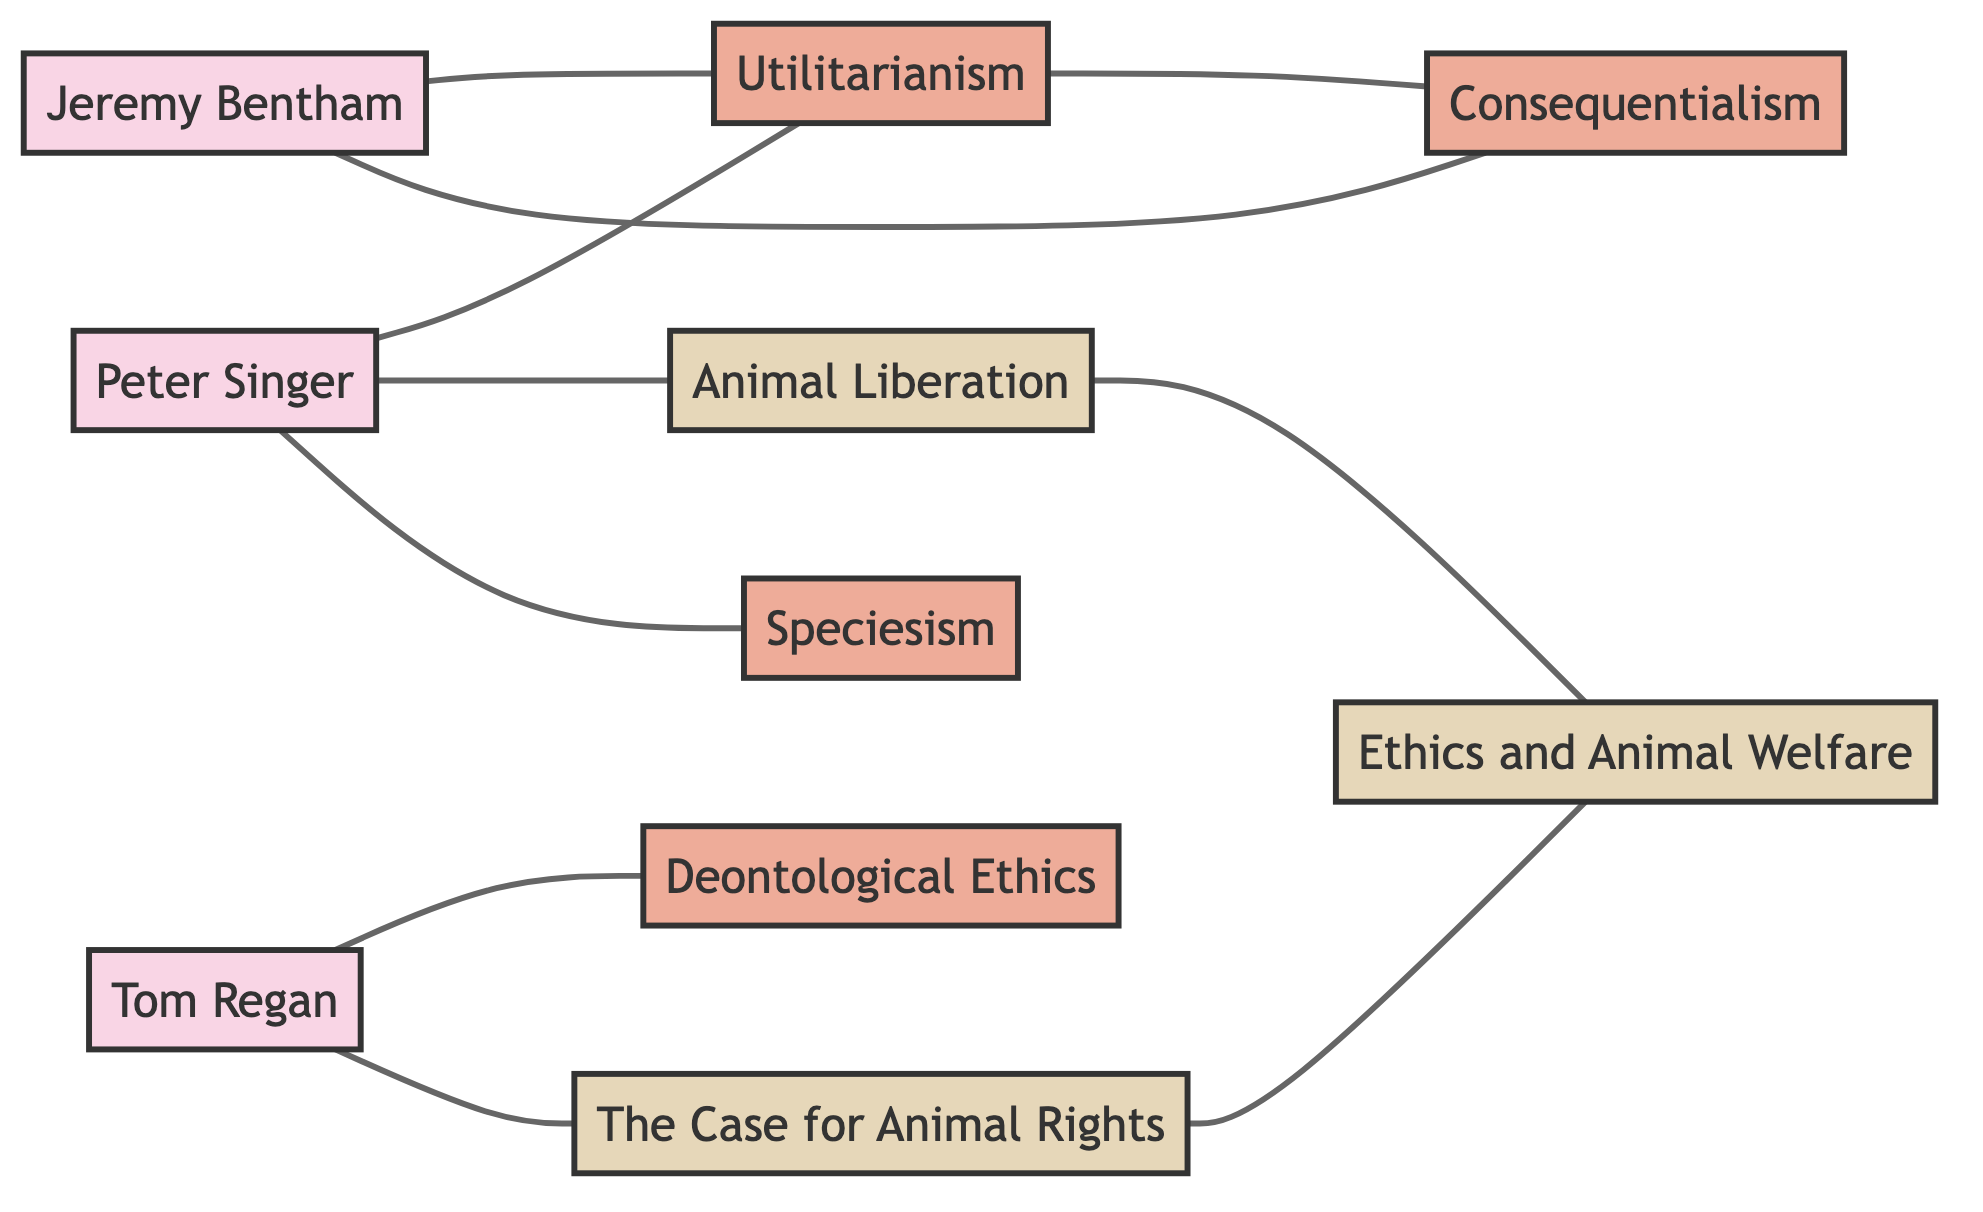What is the total number of nodes in the diagram? To find the total number of nodes, you count each unique entry in the nodes section of the data provided. There are ten nodes listed: Peter Singer, Tom Regan, Jeremy Bentham, Utilitarianism, Deontological Ethics, Animal Liberation, The Case for Animal Rights, Ethics and Animal Welfare, Consequentialism, and Speciesism.
Answer: 10 Which ethical theory is directly connected to Peter Singer? By examining the edges connected to Peter Singer, you can see that Utilitarianism, Animal Liberation, and Speciesism are directly connected to him. The question asks for one specifically, and Utilitarianism is listed as a direct connection.
Answer: Utilitarianism How many books are represented in the diagram? In the nodes section, the books identified are Animal Liberation, The Case for Animal Rights, and Ethics and Animal Welfare. By counting these, you can determine there are three books represented in the diagram.
Answer: 3 Which ethical philosopher is associated with Deontological Ethics? Looking at the edges, Tom Regan is the only ethical theorist connected to Deontological Ethics. Therefore, the answer to the question is simply Tom Regan.
Answer: Tom Regan What concept connects Animal Liberation and Ethics and Animal Welfare? The direct connection between Animal Liberation and Ethics and Animal Welfare is represented as an edge in the diagram. It clearly shows that Animal Liberation leads to Ethics and Animal Welfare.
Answer: Ethics and Animal Welfare Who is linked to both Utilitarianism and Consequentialism? Jeremy Bentham is shown as being connected to both Utilitarianism and Consequentialism in the diagram. Therefore, when asked about who links them both, the answer will be Jeremy Bentham.
Answer: Jeremy Bentham How many edges are there connecting the nodes? To find the number of edges, you count each unique pair in the edges section of the data provided. There are nine edges in total.
Answer: 9 Which ethical philosopher's work emphasizes the concept of Speciesism? The diagram indicates a connection from Peter Singer to the concept of Speciesism, highlighting his emphasis on this idea. Hence, the philosophical figure associated with Speciesism is Peter Singer.
Answer: Peter Singer What connects Tom Regan to his literature? The edge connecting Tom Regan directly to The Case for Animal Rights indicates that this book is associated with him, demonstrating that he is linked to it through that edge.
Answer: The Case for Animal Rights 